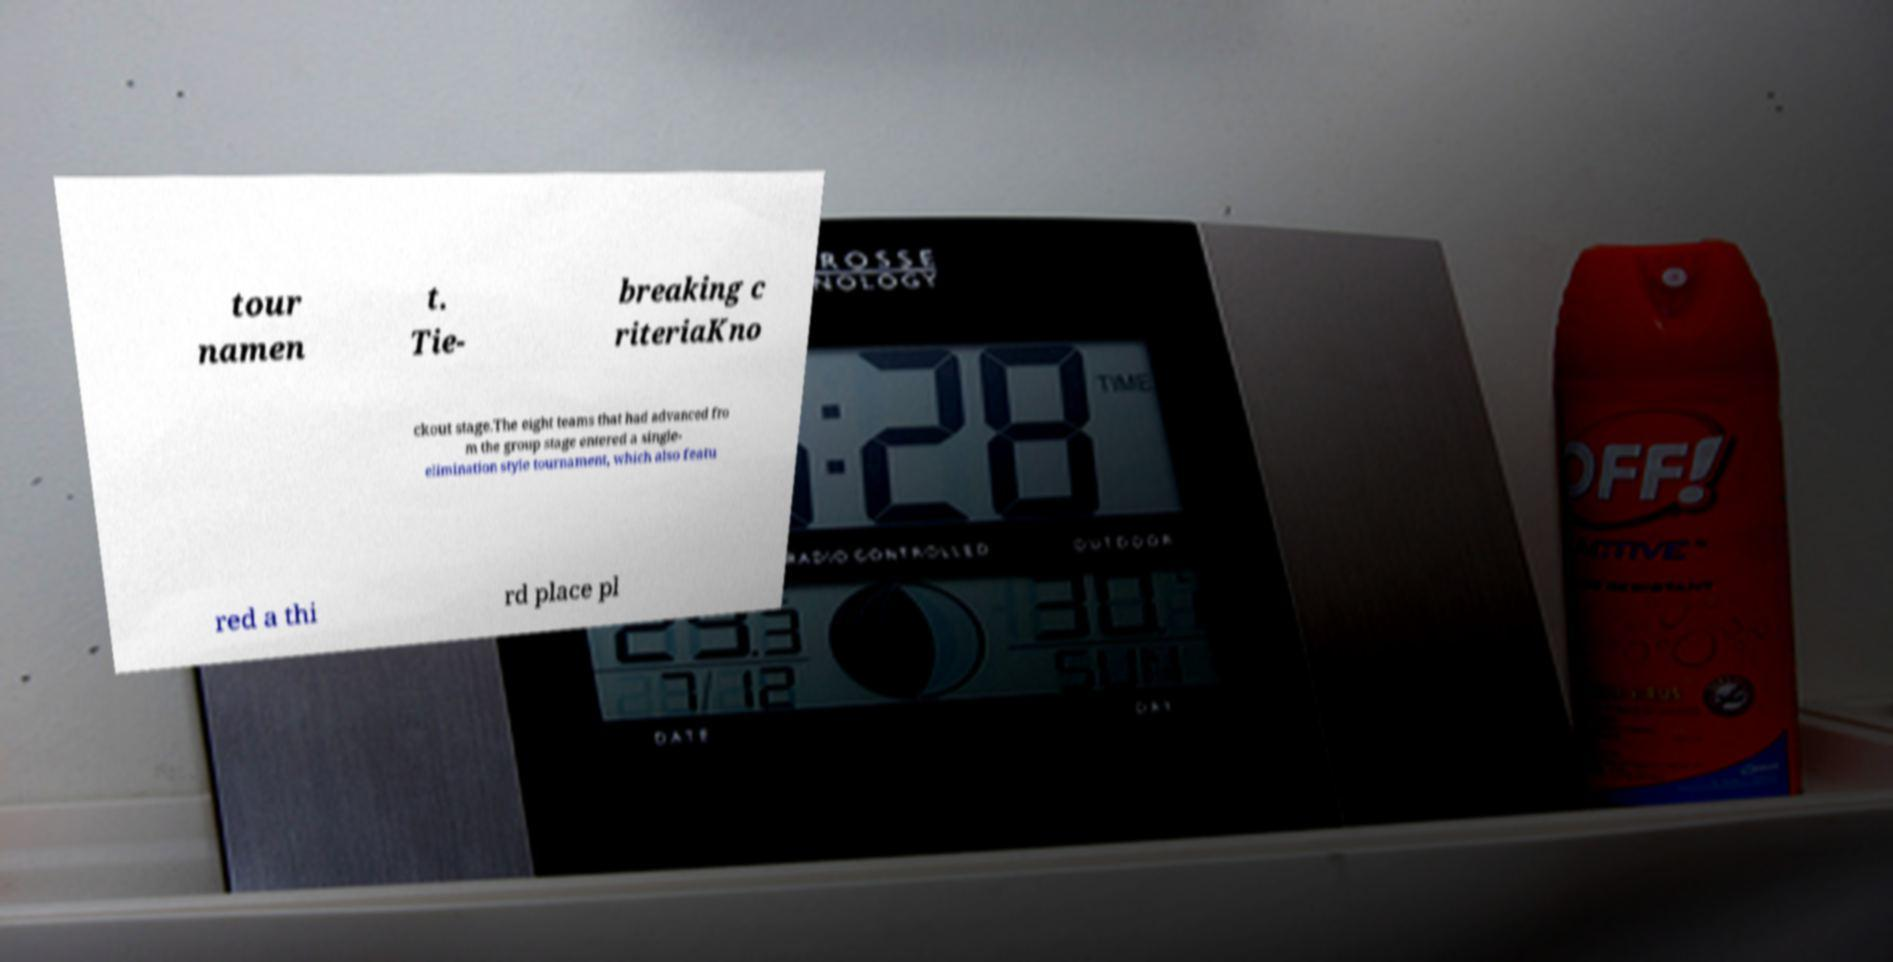Please identify and transcribe the text found in this image. tour namen t. Tie- breaking c riteriaKno ckout stage.The eight teams that had advanced fro m the group stage entered a single- elimination style tournament, which also featu red a thi rd place pl 